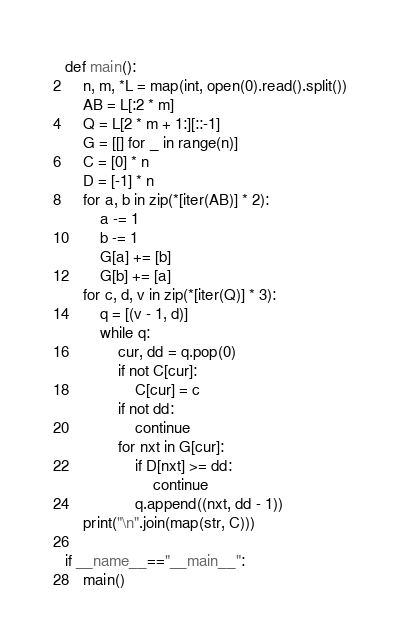<code> <loc_0><loc_0><loc_500><loc_500><_Python_>def main():
	n, m, *L = map(int, open(0).read().split())
	AB = L[:2 * m]
	Q = L[2 * m + 1:][::-1]
	G = [[] for _ in range(n)]
	C = [0] * n
	D = [-1] * n
	for a, b in zip(*[iter(AB)] * 2):
		a -= 1
		b -= 1
		G[a] += [b]
		G[b] += [a]
	for c, d, v in zip(*[iter(Q)] * 3):
		q = [(v - 1, d)]
		while q:
			cur, dd = q.pop(0)
			if not C[cur]:
				C[cur] = c
			if not dd:
				continue
			for nxt in G[cur]:
				if D[nxt] >= dd:
					continue
				q.append((nxt, dd - 1))
	print("\n".join(map(str, C)))

if __name__=="__main__":
	main()</code> 